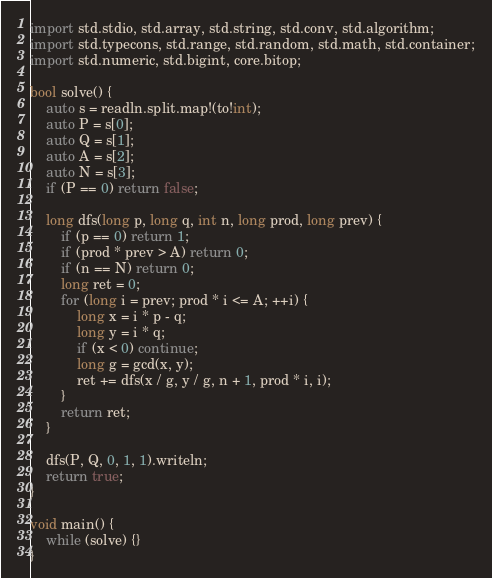<code> <loc_0><loc_0><loc_500><loc_500><_D_>import std.stdio, std.array, std.string, std.conv, std.algorithm;
import std.typecons, std.range, std.random, std.math, std.container;
import std.numeric, std.bigint, core.bitop;

bool solve() {
    auto s = readln.split.map!(to!int);
    auto P = s[0];
    auto Q = s[1];
    auto A = s[2];
    auto N = s[3];
    if (P == 0) return false;

    long dfs(long p, long q, int n, long prod, long prev) {
        if (p == 0) return 1;
        if (prod * prev > A) return 0;
        if (n == N) return 0;
        long ret = 0;
        for (long i = prev; prod * i <= A; ++i) {
            long x = i * p - q;
            long y = i * q;
            if (x < 0) continue;
            long g = gcd(x, y);
            ret += dfs(x / g, y / g, n + 1, prod * i, i);
        }
        return ret;
    }

    dfs(P, Q, 0, 1, 1).writeln;
    return true;
}

void main() {
    while (solve) {}
}

</code> 